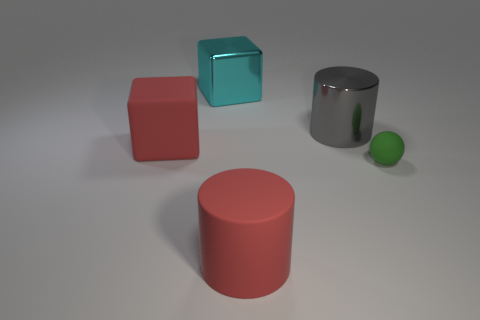Is there a rubber thing that has the same color as the big rubber block?
Offer a very short reply. Yes. What number of cubes are either red matte objects or cyan shiny things?
Your answer should be very brief. 2. Are there any big yellow metal things of the same shape as the cyan object?
Make the answer very short. No. What number of other things are there of the same color as the large matte cube?
Your response must be concise. 1. Are there fewer cylinders on the right side of the tiny thing than gray metal things?
Keep it short and to the point. Yes. What number of large blue blocks are there?
Your answer should be compact. 0. What number of other small objects have the same material as the small object?
Offer a very short reply. 0. How many objects are objects behind the tiny green thing or red rubber blocks?
Keep it short and to the point. 3. Are there fewer big gray metallic objects in front of the large gray metal cylinder than cylinders in front of the cyan thing?
Provide a short and direct response. Yes. Are there any large red objects to the left of the large red cylinder?
Give a very brief answer. Yes. 